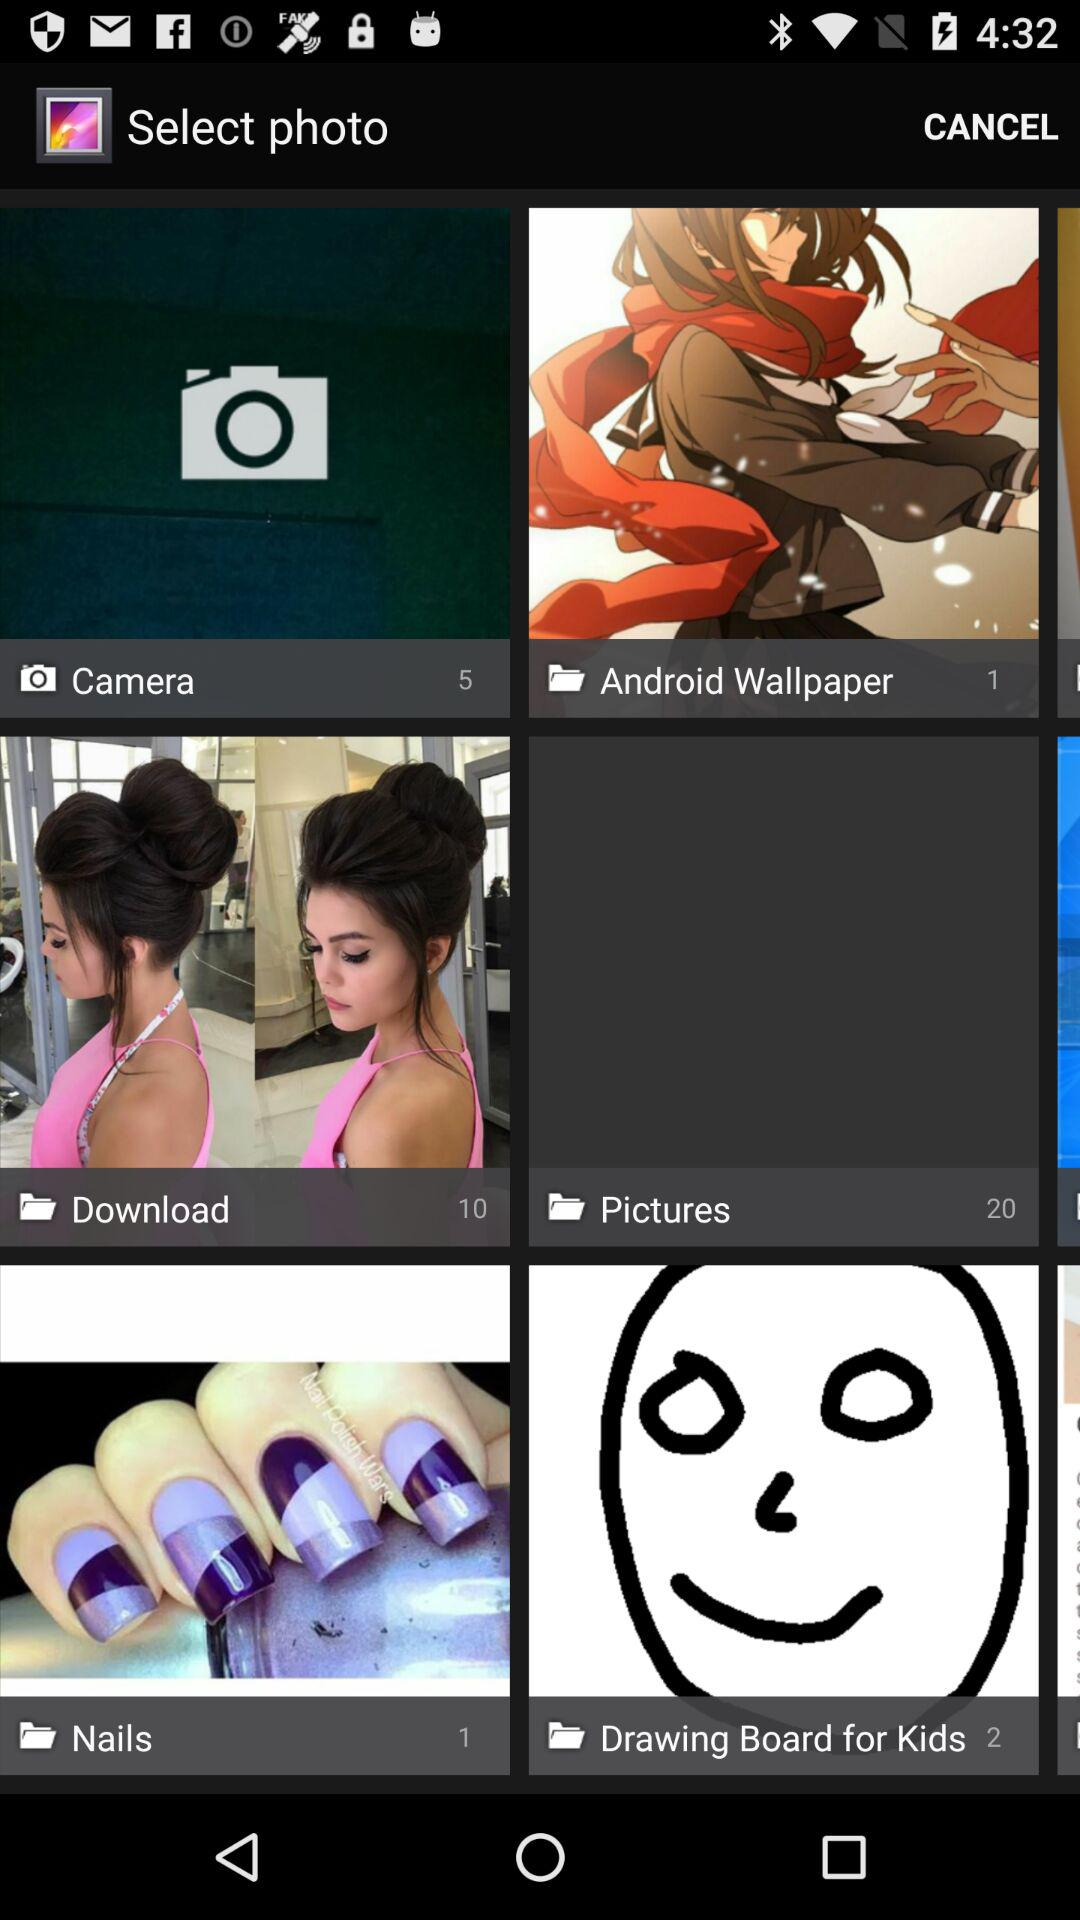What is the number of pictures shown in "Camera"? The number of pictures shown in "Camera" is 5. 